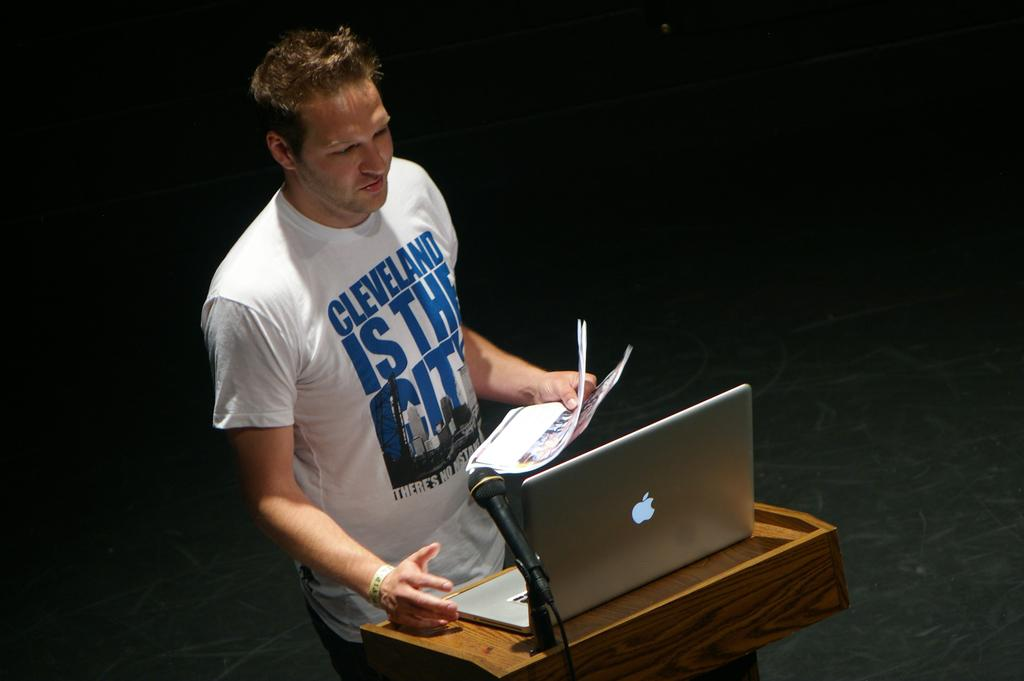<image>
Summarize the visual content of the image. A man stands at a laptop in a shirt that has Cleveland on the top of it. 